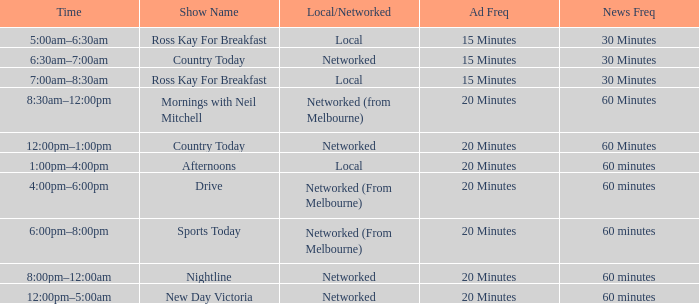What time is the show titled "mornings with neil mitchell" scheduled for? 8:30am–12:00pm. 